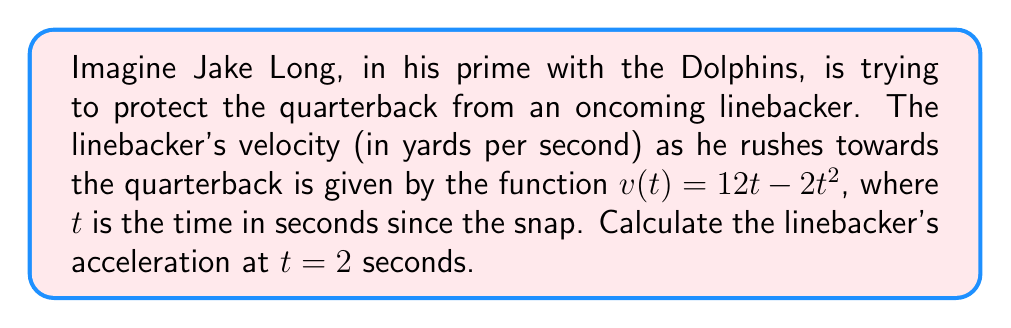Give your solution to this math problem. To solve this problem, we need to follow these steps:

1) The acceleration is the derivative of the velocity function. So, we need to find $\frac{d}{dt}v(t)$.

2) The velocity function is $v(t) = 12t - 2t^2$. Let's break this down:
   - The first term is $12t$
   - The second term is $-2t^2$

3) To find the derivative, we'll use the power rule:
   - For $12t$: The derivative is $12$ (the coefficient stays, and the exponent becomes 0)
   - For $-2t^2$: The derivative is $-2 \cdot 2t = -4t$ (the coefficient is multiplied by the exponent, and the exponent decreases by 1)

4) Combining these results:

   $$\frac{d}{dt}v(t) = 12 - 4t$$

5) This gives us the acceleration function. To find the acceleration at $t = 2$ seconds, we substitute $t = 2$ into this function:

   $$a(2) = 12 - 4(2) = 12 - 8 = 4$$

Therefore, the linebacker's acceleration at $t = 2$ seconds is 4 yards per second squared.
Answer: $4$ yards/second$^2$ 